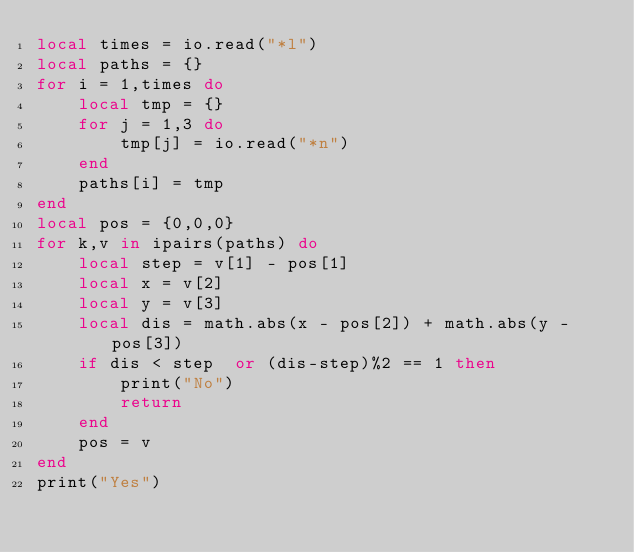Convert code to text. <code><loc_0><loc_0><loc_500><loc_500><_Lua_>local times = io.read("*l")
local paths = {}
for i = 1,times do
	local tmp = {}
	for j = 1,3 do
		tmp[j] = io.read("*n")
	end
	paths[i] = tmp
end
local pos = {0,0,0}
for k,v in ipairs(paths) do
	local step = v[1] - pos[1]
	local x = v[2]
	local y = v[3]
	local dis = math.abs(x - pos[2]) + math.abs(y - pos[3])
	if dis < step  or (dis-step)%2 == 1 then
		print("No")
		return
	end
	pos = v
end
print("Yes")</code> 